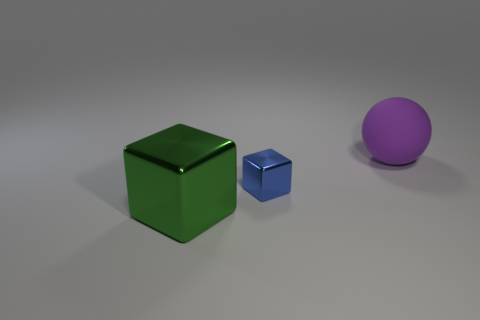Is the number of metal blocks right of the large block greater than the number of large cyan matte balls? No, the number of metal blocks to the right of the large block is not greater than the number of large cyan matte balls, because there is one small blue metal block to the right of the large green block, and there are no large cyan matte balls visible in the image. 